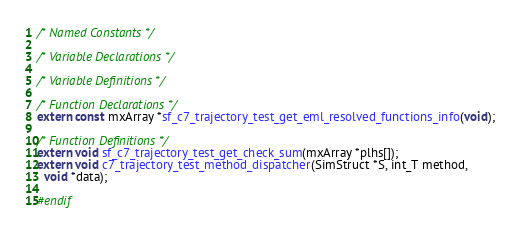Convert code to text. <code><loc_0><loc_0><loc_500><loc_500><_C_>
/* Named Constants */

/* Variable Declarations */

/* Variable Definitions */

/* Function Declarations */
extern const mxArray *sf_c7_trajectory_test_get_eml_resolved_functions_info(void);

/* Function Definitions */
extern void sf_c7_trajectory_test_get_check_sum(mxArray *plhs[]);
extern void c7_trajectory_test_method_dispatcher(SimStruct *S, int_T method,
  void *data);

#endif
</code> 